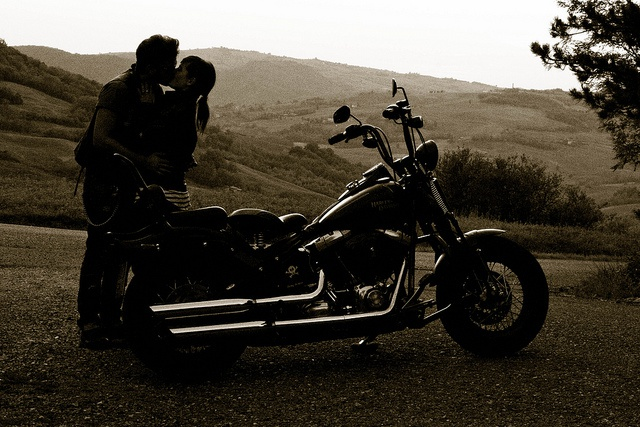Describe the objects in this image and their specific colors. I can see motorcycle in white, black, gray, and darkgray tones, people in white, black, and gray tones, people in white, black, and gray tones, and backpack in black, gray, and white tones in this image. 